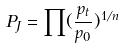Convert formula to latex. <formula><loc_0><loc_0><loc_500><loc_500>P _ { J } = \prod ( \frac { p _ { t } } { p _ { 0 } } ) ^ { 1 / n }</formula> 